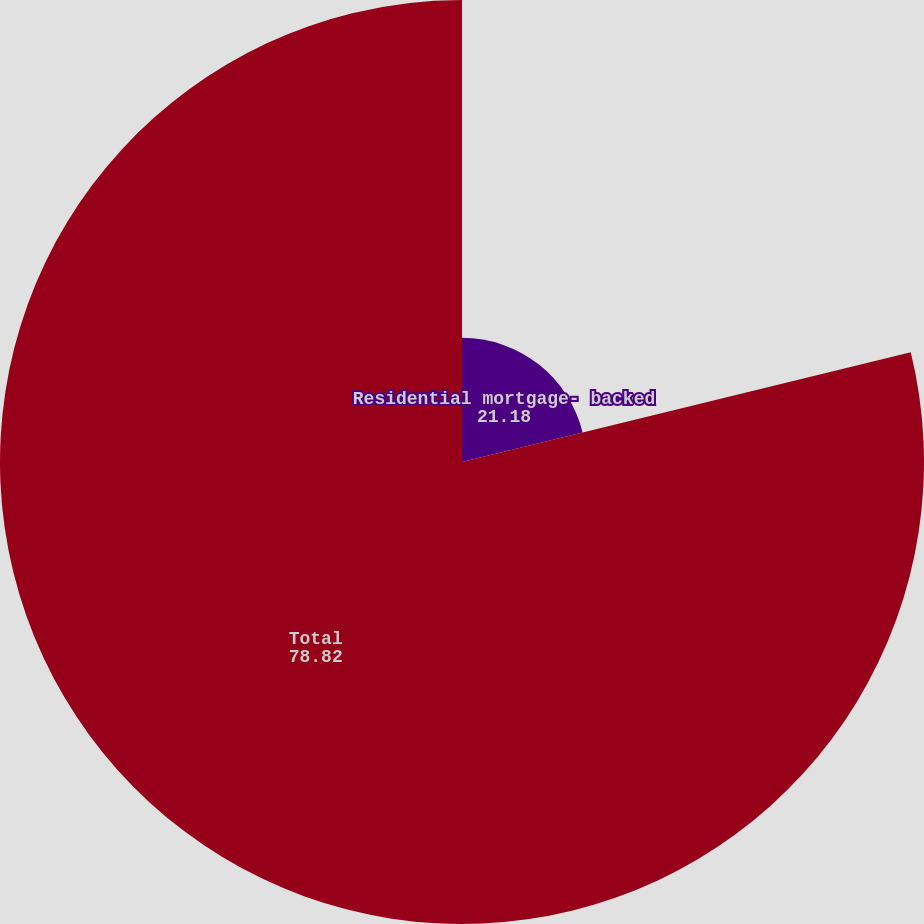<chart> <loc_0><loc_0><loc_500><loc_500><pie_chart><fcel>Residential mortgage- backed<fcel>Total<nl><fcel>21.18%<fcel>78.82%<nl></chart> 